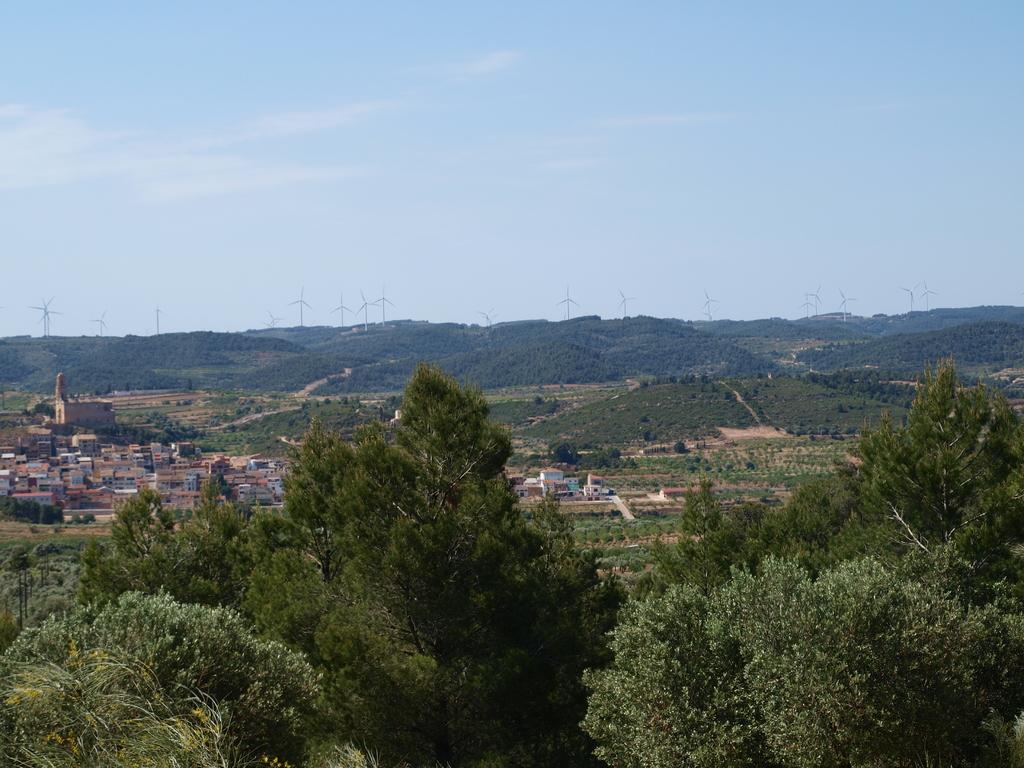What type of vegetation can be seen in the image? There are trees in the image. What is visible on the ground in the image? The ground is visible in the image. What type of structures can be seen in the image? There are houses in the image. What type of energy-generating structures are present in the image? There are windmills in the image. What part of the natural environment is visible in the background of the image? The sky is visible in the background of the image. What type of drug can be seen in the image? There is no drug present in the image. What route is depicted in the image? There is no route depicted in the image. What type of sea creatures can be seen in the image? There is no sea or sea creatures present in the image. 